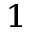<formula> <loc_0><loc_0><loc_500><loc_500>^ { 1 }</formula> 